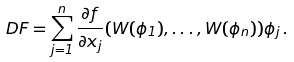Convert formula to latex. <formula><loc_0><loc_0><loc_500><loc_500>D F = \sum _ { j = 1 } ^ { n } \frac { \partial f } { \partial x _ { j } } ( W ( \phi _ { 1 } ) , \dots , W ( \phi _ { n } ) ) \phi _ { j } \, .</formula> 